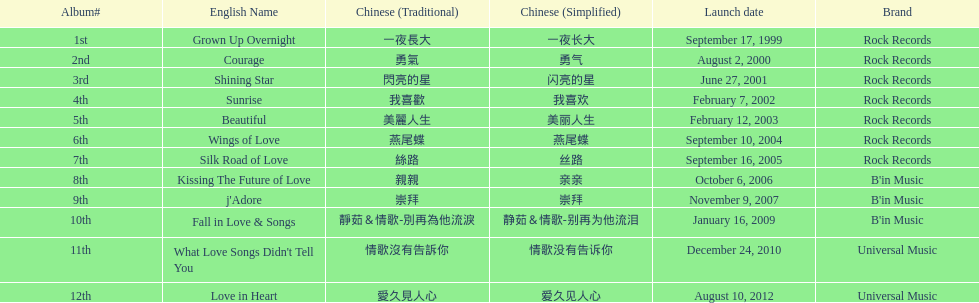What songs were on b'in music or universal music? Kissing The Future of Love, j'Adore, Fall in Love & Songs, What Love Songs Didn't Tell You, Love in Heart. 